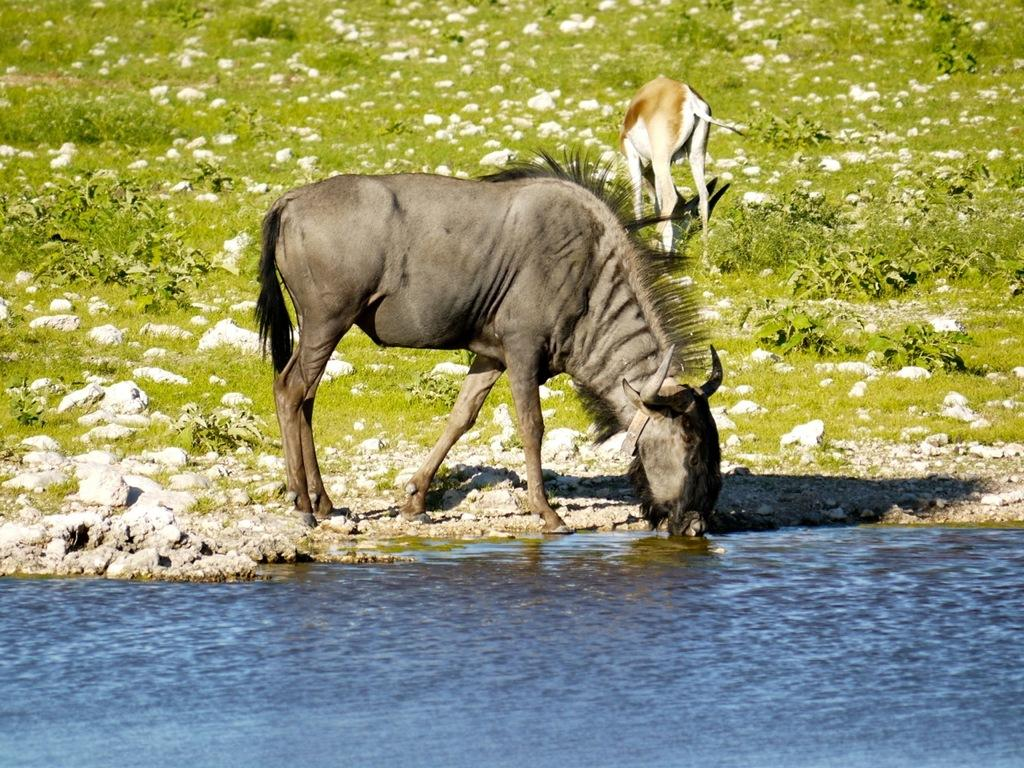What types of living organisms can be seen in the image? There are animals in the image. What natural element is present in the image? There is water visible in the image. What type of vegetation can be seen in the image? There are plants in the image. Can you see any cobwebs in the image? There is no mention of cobwebs in the image, so we cannot determine if any are present. 